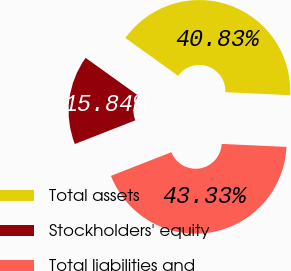Convert chart. <chart><loc_0><loc_0><loc_500><loc_500><pie_chart><fcel>Total assets<fcel>Stockholders' equity<fcel>Total liabilities and<nl><fcel>40.83%<fcel>15.84%<fcel>43.33%<nl></chart> 